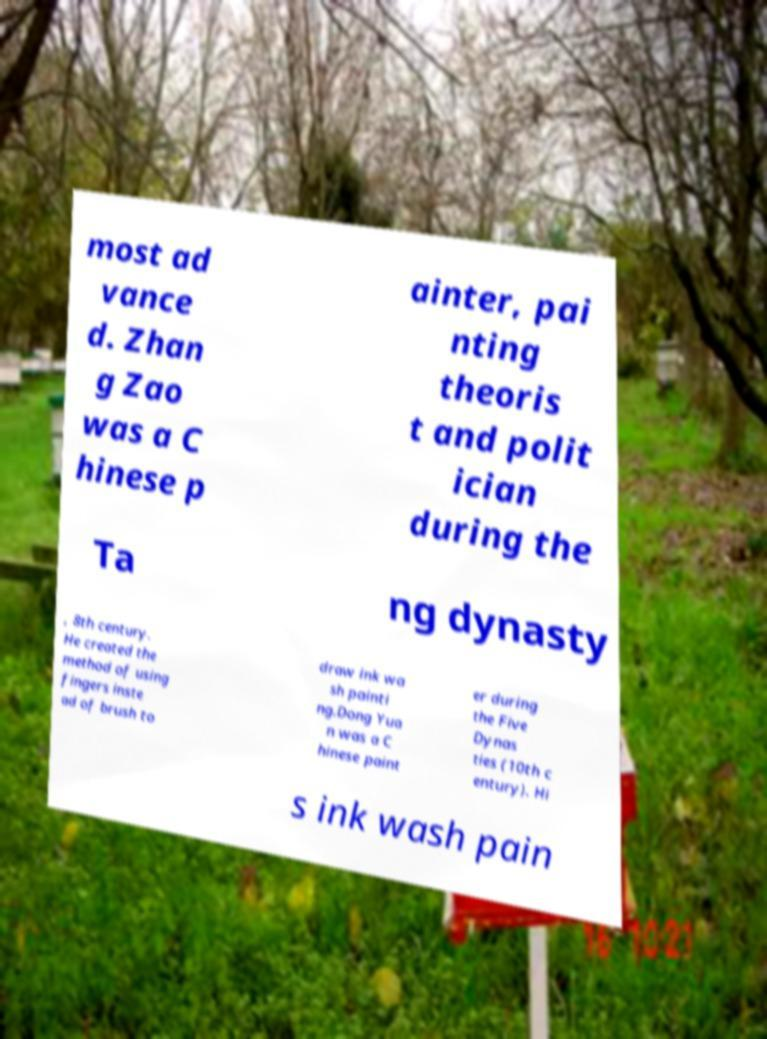Can you read and provide the text displayed in the image?This photo seems to have some interesting text. Can you extract and type it out for me? most ad vance d. Zhan g Zao was a C hinese p ainter, pai nting theoris t and polit ician during the Ta ng dynasty , 8th century. He created the method of using fingers inste ad of brush to draw ink wa sh painti ng.Dong Yua n was a C hinese paint er during the Five Dynas ties (10th c entury). Hi s ink wash pain 